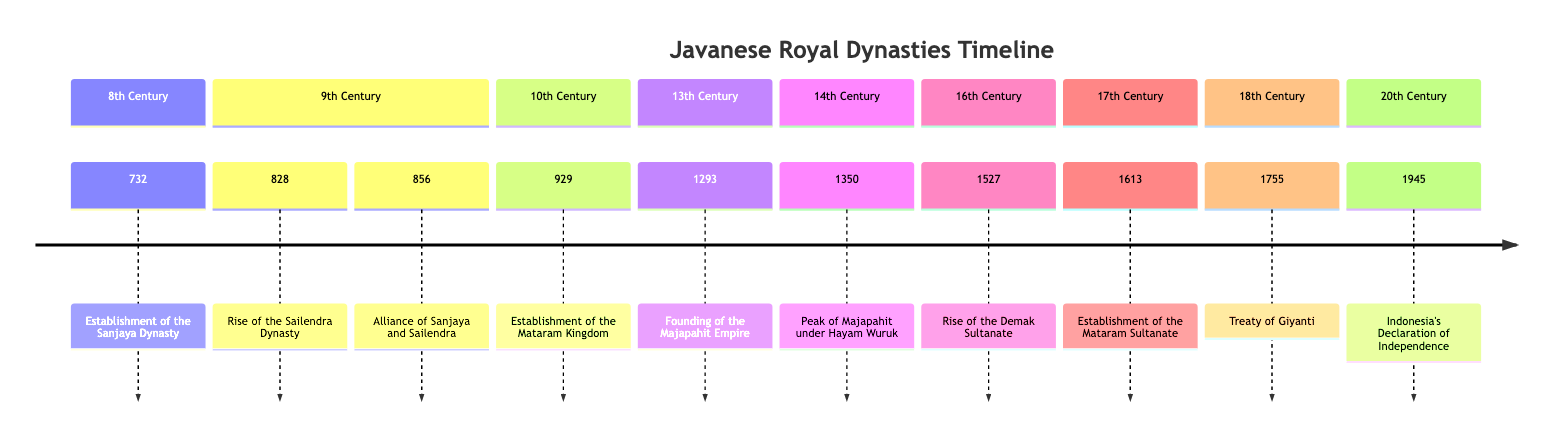What significant event happened in 732? According to the timeline, the establishment of the Sanjaya Dynasty by King Sanjaya is noted as occurring in 732. This marks the beginning of the Sanjaya dynasty's rule over central Java.
Answer: Establishment of the Sanjaya Dynasty Which dynasty rose in prominence in 828? The timeline specifies that the Sailendra Dynasty rises in prominence in 828, known for its Mahayana Buddhist influence and marked by the construction of Borobudur Temple.
Answer: Sailendra Dynasty How many dynasties are mentioned in the 9th Century? The timeline lists two events pertaining to two dynasties in the 9th Century: the rise of the Sailendra Dynasty and the alliance formed through the marriage of King Rakai Pikatan and Pramodhawardhani.
Answer: 2 What was the relationship between Sanjaya and Sailendra in 856? The timeline describes that in 856, King Rakai Pikatan's marriage to Pramodhawardhani established an alliance between the Sanjaya and Sailendra dynasties, contributing to political stability.
Answer: Alliance During which century was the Majapahit Empire founded? Referring to the diagram, the founding of the Majapahit Empire occurred in 1293, which is in the 13th Century as indicated in the timeline.
Answer: 13th Century What major event is associated with the year 1755? The timeline indicates that the Treaty of Giyanti was signed in 1755, which resulted in the division of the Mataram Sultanate into the Yogyakarta Sultanate and Surakarta Sunanate.
Answer: Treaty of Giyanti Which ruler is noted for the peak of Majapahit in 1350? The timeline mentions that King Hayam Wuruk is recognized for the peak of the Majapahit Empire in 1350, supported by Prime Minister Gajah Mada.
Answer: King Hayam Wuruk What significant event occurred in 1945 regarding Indonesian governance? According to the diagram, Indonesia's Declaration of Independence took place in 1945, marking major changes in royal power and governance structures in Java.
Answer: Indonesia's Declaration of Independence What notable temple was constructed during the Sailendra Dynasty's prominence? The timeline specifies that during the prominence of the Sailendra Dynasty, the Borobudur Temple was constructed, signifying a key cultural achievement.
Answer: Borobudur Temple 